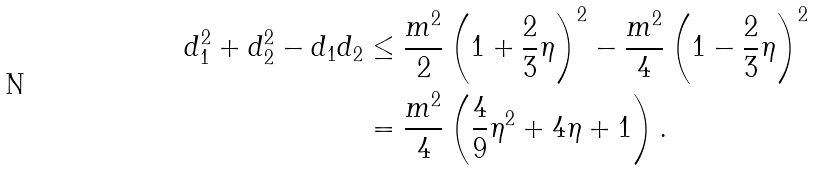<formula> <loc_0><loc_0><loc_500><loc_500>d _ { 1 } ^ { 2 } + d _ { 2 } ^ { 2 } - d _ { 1 } d _ { 2 } & \leq \frac { m ^ { 2 } } { 2 } \left ( 1 + \frac { 2 } { 3 } \eta \right ) ^ { 2 } - \frac { m ^ { 2 } } { 4 } \left ( 1 - \frac { 2 } { 3 } \eta \right ) ^ { 2 } \\ & = \frac { m ^ { 2 } } { 4 } \left ( \frac { 4 } { 9 } \eta ^ { 2 } + 4 \eta + 1 \right ) .</formula> 